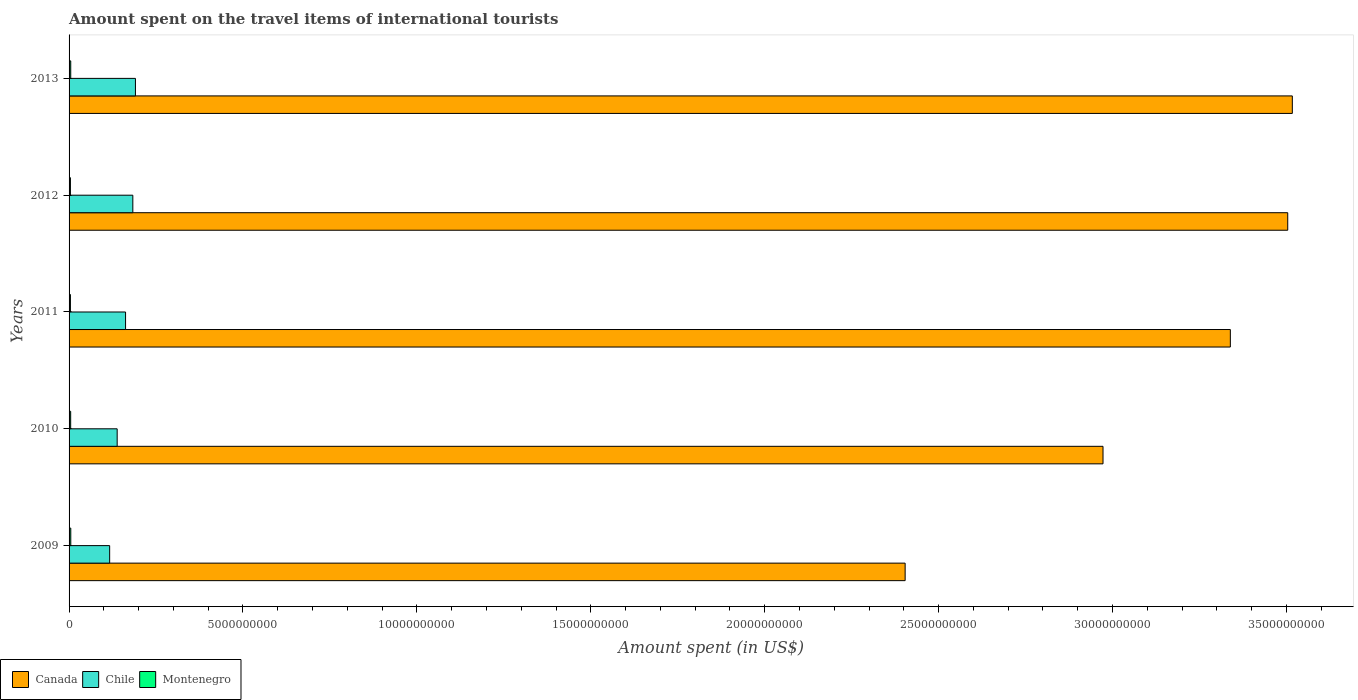How many different coloured bars are there?
Your answer should be very brief. 3. Are the number of bars on each tick of the Y-axis equal?
Offer a very short reply. Yes. How many bars are there on the 2nd tick from the top?
Your response must be concise. 3. What is the label of the 2nd group of bars from the top?
Make the answer very short. 2012. In how many cases, is the number of bars for a given year not equal to the number of legend labels?
Give a very brief answer. 0. What is the amount spent on the travel items of international tourists in Chile in 2010?
Your response must be concise. 1.38e+09. Across all years, what is the maximum amount spent on the travel items of international tourists in Canada?
Your response must be concise. 3.52e+1. Across all years, what is the minimum amount spent on the travel items of international tourists in Canada?
Your answer should be compact. 2.40e+1. In which year was the amount spent on the travel items of international tourists in Chile maximum?
Your answer should be compact. 2013. In which year was the amount spent on the travel items of international tourists in Montenegro minimum?
Keep it short and to the point. 2011. What is the total amount spent on the travel items of international tourists in Montenegro in the graph?
Ensure brevity in your answer.  2.21e+08. What is the difference between the amount spent on the travel items of international tourists in Chile in 2009 and the amount spent on the travel items of international tourists in Canada in 2012?
Ensure brevity in your answer.  -3.39e+1. What is the average amount spent on the travel items of international tourists in Montenegro per year?
Your answer should be very brief. 4.42e+07. In the year 2012, what is the difference between the amount spent on the travel items of international tourists in Chile and amount spent on the travel items of international tourists in Montenegro?
Ensure brevity in your answer.  1.79e+09. In how many years, is the amount spent on the travel items of international tourists in Montenegro greater than 6000000000 US$?
Provide a succinct answer. 0. What is the ratio of the amount spent on the travel items of international tourists in Montenegro in 2011 to that in 2013?
Make the answer very short. 0.81. Is the amount spent on the travel items of international tourists in Montenegro in 2009 less than that in 2011?
Make the answer very short. No. Is the difference between the amount spent on the travel items of international tourists in Chile in 2012 and 2013 greater than the difference between the amount spent on the travel items of international tourists in Montenegro in 2012 and 2013?
Your answer should be compact. No. What is the difference between the highest and the second highest amount spent on the travel items of international tourists in Chile?
Your answer should be very brief. 7.50e+07. What is the difference between the highest and the lowest amount spent on the travel items of international tourists in Chile?
Keep it short and to the point. 7.41e+08. In how many years, is the amount spent on the travel items of international tourists in Montenegro greater than the average amount spent on the travel items of international tourists in Montenegro taken over all years?
Your answer should be compact. 3. Is the sum of the amount spent on the travel items of international tourists in Montenegro in 2011 and 2013 greater than the maximum amount spent on the travel items of international tourists in Chile across all years?
Provide a succinct answer. No. What does the 3rd bar from the top in 2013 represents?
Provide a short and direct response. Canada. What does the 3rd bar from the bottom in 2013 represents?
Ensure brevity in your answer.  Montenegro. Is it the case that in every year, the sum of the amount spent on the travel items of international tourists in Montenegro and amount spent on the travel items of international tourists in Chile is greater than the amount spent on the travel items of international tourists in Canada?
Offer a very short reply. No. How many bars are there?
Your answer should be very brief. 15. Are all the bars in the graph horizontal?
Offer a terse response. Yes. How many years are there in the graph?
Provide a succinct answer. 5. What is the title of the graph?
Your answer should be very brief. Amount spent on the travel items of international tourists. What is the label or title of the X-axis?
Provide a succinct answer. Amount spent (in US$). What is the Amount spent (in US$) of Canada in 2009?
Your answer should be very brief. 2.40e+1. What is the Amount spent (in US$) in Chile in 2009?
Give a very brief answer. 1.17e+09. What is the Amount spent (in US$) of Montenegro in 2009?
Offer a very short reply. 4.90e+07. What is the Amount spent (in US$) of Canada in 2010?
Ensure brevity in your answer.  2.97e+1. What is the Amount spent (in US$) in Chile in 2010?
Your answer should be compact. 1.38e+09. What is the Amount spent (in US$) in Montenegro in 2010?
Ensure brevity in your answer.  4.60e+07. What is the Amount spent (in US$) in Canada in 2011?
Keep it short and to the point. 3.34e+1. What is the Amount spent (in US$) in Chile in 2011?
Keep it short and to the point. 1.62e+09. What is the Amount spent (in US$) in Montenegro in 2011?
Offer a very short reply. 3.90e+07. What is the Amount spent (in US$) of Canada in 2012?
Give a very brief answer. 3.50e+1. What is the Amount spent (in US$) in Chile in 2012?
Give a very brief answer. 1.83e+09. What is the Amount spent (in US$) in Montenegro in 2012?
Give a very brief answer. 3.90e+07. What is the Amount spent (in US$) in Canada in 2013?
Provide a succinct answer. 3.52e+1. What is the Amount spent (in US$) in Chile in 2013?
Keep it short and to the point. 1.91e+09. What is the Amount spent (in US$) in Montenegro in 2013?
Offer a very short reply. 4.80e+07. Across all years, what is the maximum Amount spent (in US$) in Canada?
Ensure brevity in your answer.  3.52e+1. Across all years, what is the maximum Amount spent (in US$) of Chile?
Offer a very short reply. 1.91e+09. Across all years, what is the maximum Amount spent (in US$) in Montenegro?
Keep it short and to the point. 4.90e+07. Across all years, what is the minimum Amount spent (in US$) in Canada?
Your response must be concise. 2.40e+1. Across all years, what is the minimum Amount spent (in US$) of Chile?
Provide a short and direct response. 1.17e+09. Across all years, what is the minimum Amount spent (in US$) in Montenegro?
Your answer should be very brief. 3.90e+07. What is the total Amount spent (in US$) of Canada in the graph?
Your answer should be compact. 1.57e+11. What is the total Amount spent (in US$) in Chile in the graph?
Ensure brevity in your answer.  7.92e+09. What is the total Amount spent (in US$) of Montenegro in the graph?
Provide a succinct answer. 2.21e+08. What is the difference between the Amount spent (in US$) of Canada in 2009 and that in 2010?
Ensure brevity in your answer.  -5.69e+09. What is the difference between the Amount spent (in US$) of Chile in 2009 and that in 2010?
Offer a terse response. -2.16e+08. What is the difference between the Amount spent (in US$) in Canada in 2009 and that in 2011?
Make the answer very short. -9.35e+09. What is the difference between the Amount spent (in US$) of Chile in 2009 and that in 2011?
Provide a short and direct response. -4.57e+08. What is the difference between the Amount spent (in US$) in Montenegro in 2009 and that in 2011?
Give a very brief answer. 1.00e+07. What is the difference between the Amount spent (in US$) in Canada in 2009 and that in 2012?
Your response must be concise. -1.10e+1. What is the difference between the Amount spent (in US$) of Chile in 2009 and that in 2012?
Provide a short and direct response. -6.66e+08. What is the difference between the Amount spent (in US$) in Canada in 2009 and that in 2013?
Keep it short and to the point. -1.11e+1. What is the difference between the Amount spent (in US$) of Chile in 2009 and that in 2013?
Make the answer very short. -7.41e+08. What is the difference between the Amount spent (in US$) in Montenegro in 2009 and that in 2013?
Your answer should be compact. 1.00e+06. What is the difference between the Amount spent (in US$) in Canada in 2010 and that in 2011?
Provide a short and direct response. -3.66e+09. What is the difference between the Amount spent (in US$) in Chile in 2010 and that in 2011?
Provide a short and direct response. -2.41e+08. What is the difference between the Amount spent (in US$) of Canada in 2010 and that in 2012?
Offer a very short reply. -5.31e+09. What is the difference between the Amount spent (in US$) in Chile in 2010 and that in 2012?
Ensure brevity in your answer.  -4.50e+08. What is the difference between the Amount spent (in US$) of Montenegro in 2010 and that in 2012?
Provide a short and direct response. 7.00e+06. What is the difference between the Amount spent (in US$) in Canada in 2010 and that in 2013?
Offer a very short reply. -5.44e+09. What is the difference between the Amount spent (in US$) in Chile in 2010 and that in 2013?
Your answer should be very brief. -5.25e+08. What is the difference between the Amount spent (in US$) in Canada in 2011 and that in 2012?
Your answer should be compact. -1.65e+09. What is the difference between the Amount spent (in US$) of Chile in 2011 and that in 2012?
Offer a very short reply. -2.09e+08. What is the difference between the Amount spent (in US$) in Montenegro in 2011 and that in 2012?
Provide a succinct answer. 0. What is the difference between the Amount spent (in US$) of Canada in 2011 and that in 2013?
Ensure brevity in your answer.  -1.78e+09. What is the difference between the Amount spent (in US$) of Chile in 2011 and that in 2013?
Provide a succinct answer. -2.84e+08. What is the difference between the Amount spent (in US$) of Montenegro in 2011 and that in 2013?
Ensure brevity in your answer.  -9.00e+06. What is the difference between the Amount spent (in US$) in Canada in 2012 and that in 2013?
Ensure brevity in your answer.  -1.32e+08. What is the difference between the Amount spent (in US$) in Chile in 2012 and that in 2013?
Your response must be concise. -7.50e+07. What is the difference between the Amount spent (in US$) in Montenegro in 2012 and that in 2013?
Make the answer very short. -9.00e+06. What is the difference between the Amount spent (in US$) in Canada in 2009 and the Amount spent (in US$) in Chile in 2010?
Your answer should be very brief. 2.27e+1. What is the difference between the Amount spent (in US$) of Canada in 2009 and the Amount spent (in US$) of Montenegro in 2010?
Provide a short and direct response. 2.40e+1. What is the difference between the Amount spent (in US$) in Chile in 2009 and the Amount spent (in US$) in Montenegro in 2010?
Your response must be concise. 1.12e+09. What is the difference between the Amount spent (in US$) of Canada in 2009 and the Amount spent (in US$) of Chile in 2011?
Your answer should be very brief. 2.24e+1. What is the difference between the Amount spent (in US$) in Canada in 2009 and the Amount spent (in US$) in Montenegro in 2011?
Offer a very short reply. 2.40e+1. What is the difference between the Amount spent (in US$) of Chile in 2009 and the Amount spent (in US$) of Montenegro in 2011?
Keep it short and to the point. 1.13e+09. What is the difference between the Amount spent (in US$) of Canada in 2009 and the Amount spent (in US$) of Chile in 2012?
Keep it short and to the point. 2.22e+1. What is the difference between the Amount spent (in US$) of Canada in 2009 and the Amount spent (in US$) of Montenegro in 2012?
Your response must be concise. 2.40e+1. What is the difference between the Amount spent (in US$) of Chile in 2009 and the Amount spent (in US$) of Montenegro in 2012?
Your answer should be very brief. 1.13e+09. What is the difference between the Amount spent (in US$) in Canada in 2009 and the Amount spent (in US$) in Chile in 2013?
Offer a terse response. 2.21e+1. What is the difference between the Amount spent (in US$) in Canada in 2009 and the Amount spent (in US$) in Montenegro in 2013?
Your response must be concise. 2.40e+1. What is the difference between the Amount spent (in US$) in Chile in 2009 and the Amount spent (in US$) in Montenegro in 2013?
Your response must be concise. 1.12e+09. What is the difference between the Amount spent (in US$) in Canada in 2010 and the Amount spent (in US$) in Chile in 2011?
Give a very brief answer. 2.81e+1. What is the difference between the Amount spent (in US$) of Canada in 2010 and the Amount spent (in US$) of Montenegro in 2011?
Your answer should be compact. 2.97e+1. What is the difference between the Amount spent (in US$) of Chile in 2010 and the Amount spent (in US$) of Montenegro in 2011?
Offer a very short reply. 1.34e+09. What is the difference between the Amount spent (in US$) in Canada in 2010 and the Amount spent (in US$) in Chile in 2012?
Your answer should be compact. 2.79e+1. What is the difference between the Amount spent (in US$) of Canada in 2010 and the Amount spent (in US$) of Montenegro in 2012?
Provide a succinct answer. 2.97e+1. What is the difference between the Amount spent (in US$) of Chile in 2010 and the Amount spent (in US$) of Montenegro in 2012?
Offer a terse response. 1.34e+09. What is the difference between the Amount spent (in US$) in Canada in 2010 and the Amount spent (in US$) in Chile in 2013?
Your answer should be very brief. 2.78e+1. What is the difference between the Amount spent (in US$) in Canada in 2010 and the Amount spent (in US$) in Montenegro in 2013?
Make the answer very short. 2.97e+1. What is the difference between the Amount spent (in US$) of Chile in 2010 and the Amount spent (in US$) of Montenegro in 2013?
Provide a succinct answer. 1.34e+09. What is the difference between the Amount spent (in US$) of Canada in 2011 and the Amount spent (in US$) of Chile in 2012?
Your response must be concise. 3.16e+1. What is the difference between the Amount spent (in US$) in Canada in 2011 and the Amount spent (in US$) in Montenegro in 2012?
Offer a terse response. 3.33e+1. What is the difference between the Amount spent (in US$) of Chile in 2011 and the Amount spent (in US$) of Montenegro in 2012?
Ensure brevity in your answer.  1.58e+09. What is the difference between the Amount spent (in US$) of Canada in 2011 and the Amount spent (in US$) of Chile in 2013?
Your answer should be compact. 3.15e+1. What is the difference between the Amount spent (in US$) of Canada in 2011 and the Amount spent (in US$) of Montenegro in 2013?
Give a very brief answer. 3.33e+1. What is the difference between the Amount spent (in US$) of Chile in 2011 and the Amount spent (in US$) of Montenegro in 2013?
Give a very brief answer. 1.58e+09. What is the difference between the Amount spent (in US$) of Canada in 2012 and the Amount spent (in US$) of Chile in 2013?
Ensure brevity in your answer.  3.31e+1. What is the difference between the Amount spent (in US$) in Canada in 2012 and the Amount spent (in US$) in Montenegro in 2013?
Your answer should be very brief. 3.50e+1. What is the difference between the Amount spent (in US$) of Chile in 2012 and the Amount spent (in US$) of Montenegro in 2013?
Your answer should be compact. 1.78e+09. What is the average Amount spent (in US$) of Canada per year?
Provide a short and direct response. 3.15e+1. What is the average Amount spent (in US$) of Chile per year?
Your response must be concise. 1.58e+09. What is the average Amount spent (in US$) of Montenegro per year?
Provide a short and direct response. 4.42e+07. In the year 2009, what is the difference between the Amount spent (in US$) in Canada and Amount spent (in US$) in Chile?
Give a very brief answer. 2.29e+1. In the year 2009, what is the difference between the Amount spent (in US$) in Canada and Amount spent (in US$) in Montenegro?
Your answer should be compact. 2.40e+1. In the year 2009, what is the difference between the Amount spent (in US$) in Chile and Amount spent (in US$) in Montenegro?
Keep it short and to the point. 1.12e+09. In the year 2010, what is the difference between the Amount spent (in US$) of Canada and Amount spent (in US$) of Chile?
Make the answer very short. 2.83e+1. In the year 2010, what is the difference between the Amount spent (in US$) of Canada and Amount spent (in US$) of Montenegro?
Give a very brief answer. 2.97e+1. In the year 2010, what is the difference between the Amount spent (in US$) of Chile and Amount spent (in US$) of Montenegro?
Offer a terse response. 1.34e+09. In the year 2011, what is the difference between the Amount spent (in US$) in Canada and Amount spent (in US$) in Chile?
Your response must be concise. 3.18e+1. In the year 2011, what is the difference between the Amount spent (in US$) of Canada and Amount spent (in US$) of Montenegro?
Your answer should be very brief. 3.33e+1. In the year 2011, what is the difference between the Amount spent (in US$) in Chile and Amount spent (in US$) in Montenegro?
Keep it short and to the point. 1.58e+09. In the year 2012, what is the difference between the Amount spent (in US$) in Canada and Amount spent (in US$) in Chile?
Give a very brief answer. 3.32e+1. In the year 2012, what is the difference between the Amount spent (in US$) of Canada and Amount spent (in US$) of Montenegro?
Keep it short and to the point. 3.50e+1. In the year 2012, what is the difference between the Amount spent (in US$) in Chile and Amount spent (in US$) in Montenegro?
Provide a succinct answer. 1.79e+09. In the year 2013, what is the difference between the Amount spent (in US$) in Canada and Amount spent (in US$) in Chile?
Give a very brief answer. 3.33e+1. In the year 2013, what is the difference between the Amount spent (in US$) in Canada and Amount spent (in US$) in Montenegro?
Provide a short and direct response. 3.51e+1. In the year 2013, what is the difference between the Amount spent (in US$) in Chile and Amount spent (in US$) in Montenegro?
Offer a terse response. 1.86e+09. What is the ratio of the Amount spent (in US$) of Canada in 2009 to that in 2010?
Give a very brief answer. 0.81. What is the ratio of the Amount spent (in US$) of Chile in 2009 to that in 2010?
Your response must be concise. 0.84. What is the ratio of the Amount spent (in US$) of Montenegro in 2009 to that in 2010?
Your response must be concise. 1.07. What is the ratio of the Amount spent (in US$) in Canada in 2009 to that in 2011?
Your answer should be compact. 0.72. What is the ratio of the Amount spent (in US$) in Chile in 2009 to that in 2011?
Your response must be concise. 0.72. What is the ratio of the Amount spent (in US$) in Montenegro in 2009 to that in 2011?
Make the answer very short. 1.26. What is the ratio of the Amount spent (in US$) of Canada in 2009 to that in 2012?
Provide a succinct answer. 0.69. What is the ratio of the Amount spent (in US$) in Chile in 2009 to that in 2012?
Make the answer very short. 0.64. What is the ratio of the Amount spent (in US$) in Montenegro in 2009 to that in 2012?
Give a very brief answer. 1.26. What is the ratio of the Amount spent (in US$) of Canada in 2009 to that in 2013?
Your answer should be very brief. 0.68. What is the ratio of the Amount spent (in US$) of Chile in 2009 to that in 2013?
Provide a succinct answer. 0.61. What is the ratio of the Amount spent (in US$) in Montenegro in 2009 to that in 2013?
Make the answer very short. 1.02. What is the ratio of the Amount spent (in US$) of Canada in 2010 to that in 2011?
Keep it short and to the point. 0.89. What is the ratio of the Amount spent (in US$) in Chile in 2010 to that in 2011?
Make the answer very short. 0.85. What is the ratio of the Amount spent (in US$) in Montenegro in 2010 to that in 2011?
Provide a short and direct response. 1.18. What is the ratio of the Amount spent (in US$) of Canada in 2010 to that in 2012?
Make the answer very short. 0.85. What is the ratio of the Amount spent (in US$) of Chile in 2010 to that in 2012?
Offer a very short reply. 0.75. What is the ratio of the Amount spent (in US$) of Montenegro in 2010 to that in 2012?
Your answer should be compact. 1.18. What is the ratio of the Amount spent (in US$) of Canada in 2010 to that in 2013?
Make the answer very short. 0.85. What is the ratio of the Amount spent (in US$) of Chile in 2010 to that in 2013?
Your response must be concise. 0.72. What is the ratio of the Amount spent (in US$) of Canada in 2011 to that in 2012?
Your answer should be very brief. 0.95. What is the ratio of the Amount spent (in US$) of Chile in 2011 to that in 2012?
Your answer should be compact. 0.89. What is the ratio of the Amount spent (in US$) of Canada in 2011 to that in 2013?
Provide a succinct answer. 0.95. What is the ratio of the Amount spent (in US$) of Chile in 2011 to that in 2013?
Ensure brevity in your answer.  0.85. What is the ratio of the Amount spent (in US$) in Montenegro in 2011 to that in 2013?
Your response must be concise. 0.81. What is the ratio of the Amount spent (in US$) of Canada in 2012 to that in 2013?
Offer a terse response. 1. What is the ratio of the Amount spent (in US$) of Chile in 2012 to that in 2013?
Make the answer very short. 0.96. What is the ratio of the Amount spent (in US$) of Montenegro in 2012 to that in 2013?
Ensure brevity in your answer.  0.81. What is the difference between the highest and the second highest Amount spent (in US$) of Canada?
Keep it short and to the point. 1.32e+08. What is the difference between the highest and the second highest Amount spent (in US$) of Chile?
Your response must be concise. 7.50e+07. What is the difference between the highest and the lowest Amount spent (in US$) of Canada?
Make the answer very short. 1.11e+1. What is the difference between the highest and the lowest Amount spent (in US$) of Chile?
Keep it short and to the point. 7.41e+08. What is the difference between the highest and the lowest Amount spent (in US$) of Montenegro?
Your answer should be very brief. 1.00e+07. 